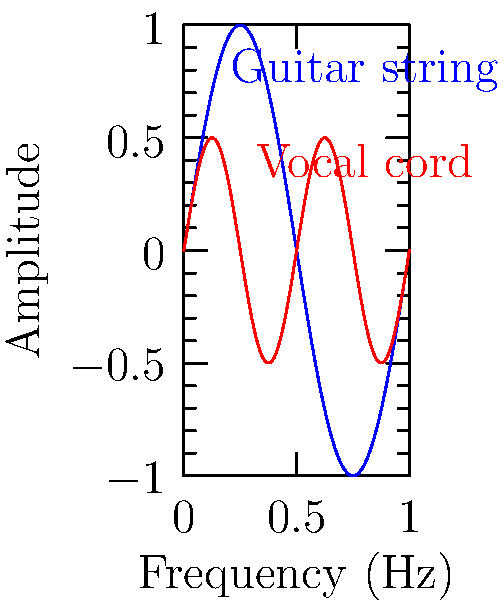Given the graph showing the vibration patterns of a guitar string and human vocal cords, which harmonic of the guitar string most closely matches the fundamental frequency of the vocal cords? To determine which harmonic of the guitar string matches the fundamental frequency of the vocal cords, we need to analyze the graph:

1. The blue curve represents the guitar string vibration, while the red curve represents the vocal cord vibration.

2. The fundamental frequency of the guitar string (blue) completes one full cycle in the given range.

3. The vocal cord vibration (red) completes two full cycles in the same range.

4. This means the frequency of the vocal cord vibration is twice that of the guitar string's fundamental frequency.

5. In musical terms, when a frequency is doubled, it represents the second harmonic or the first overtone.

6. Therefore, the second harmonic of the guitar string matches the fundamental frequency of the vocal cords.

7. This relationship explains why guitarists often find it natural to sing along with their instrument, as the harmonics of the guitar strings often align with vocal frequencies.
Answer: Second harmonic 